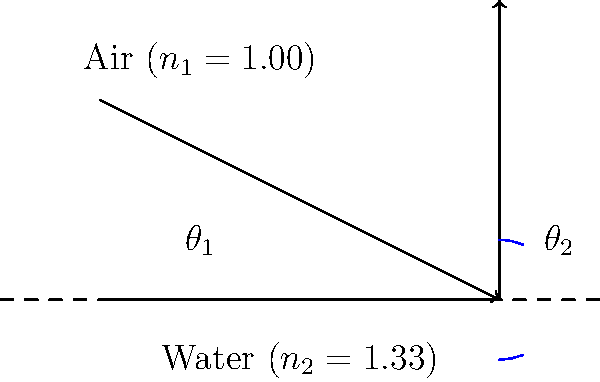As an operative, you're tasked with analyzing underwater visibility for a covert mission. A light ray travels from air ($n_1 = 1.00$) into water ($n_2 = 1.33$) at an incident angle of $\theta_1 = 50°$. Using Snell's law, calculate the angle of refraction $\theta_2$ in the water to the nearest degree. To solve this problem, we'll use Snell's law and follow these steps:

1) Recall Snell's law: $n_1 \sin(\theta_1) = n_2 \sin(\theta_2)$

2) We're given:
   $n_1 = 1.00$ (air)
   $n_2 = 1.33$ (water)
   $\theta_1 = 50°$

3) Substitute these values into Snell's law:
   $1.00 \sin(50°) = 1.33 \sin(\theta_2)$

4) Solve for $\sin(\theta_2)$:
   $\sin(\theta_2) = \frac{1.00 \sin(50°)}{1.33}$

5) Calculate:
   $\sin(\theta_2) = \frac{1.00 \cdot 0.7660}{1.33} = 0.5759$

6) To find $\theta_2$, we need to take the inverse sine (arcsin):
   $\theta_2 = \arcsin(0.5759)$

7) Calculate:
   $\theta_2 = 35.2°$

8) Rounding to the nearest degree:
   $\theta_2 \approx 35°$
Answer: 35° 